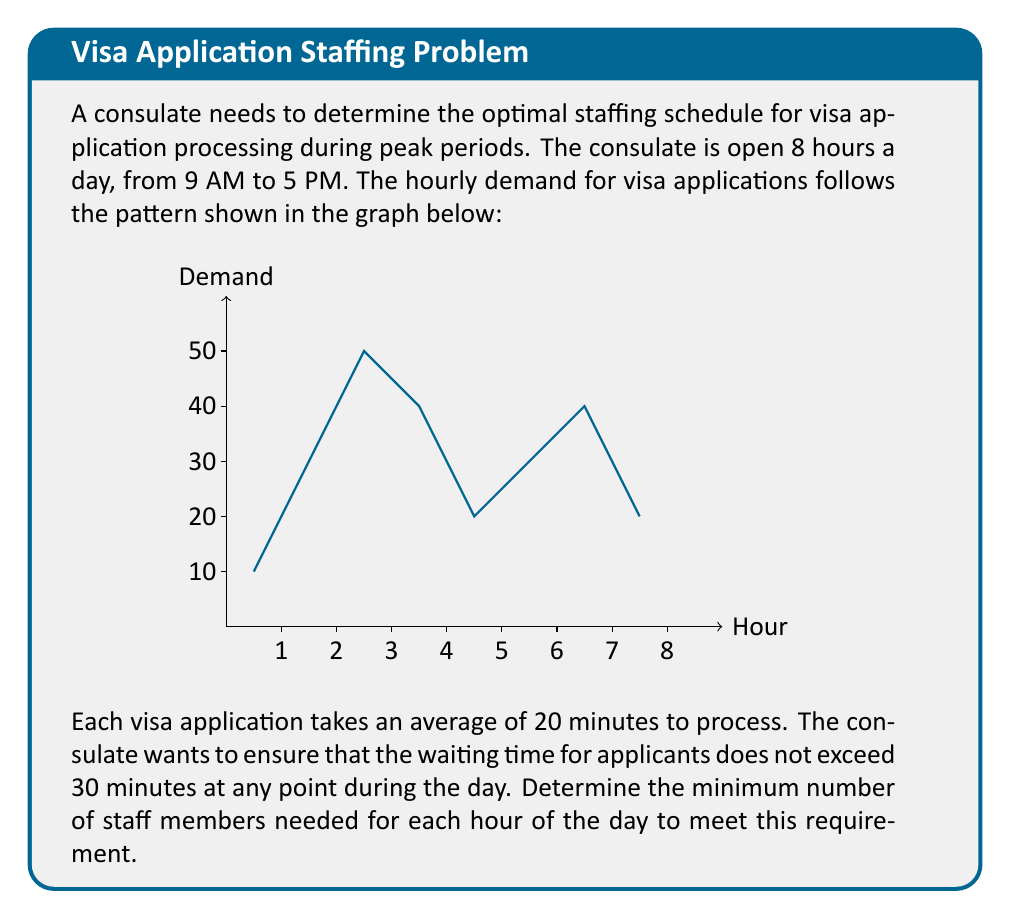Show me your answer to this math problem. Let's approach this problem step-by-step:

1) First, we need to calculate the number of applications that can be processed per hour per staff member:
   $$\text{Applications per hour} = \frac{60 \text{ minutes}}{20 \text{ minutes per application}} = 3$$

2) Now, for each hour, we need to calculate the number of staff required to process the incoming applications within 30 minutes:
   $$\text{Staff needed} = \left\lceil\frac{\text{Hourly demand}}{3 \times 0.5}\right\rceil$$
   Here, we multiply by 0.5 because we want to process all applications within 30 minutes (half an hour).

3) Let's calculate for each hour:

   Hour 1 (9-10 AM): $$\left\lceil\frac{10}{3 \times 0.5}\right\rceil = \left\lceil6.67\right\rceil = 7$$
   Hour 2 (10-11 AM): $$\left\lceil\frac{30}{3 \times 0.5}\right\rceil = \left\lceil20\right\rceil = 20$$
   Hour 3 (11-12 PM): $$\left\lceil\frac{50}{3 \times 0.5}\right\rceil = \left\lceil33.33\right\rceil = 34$$
   Hour 4 (12-1 PM): $$\left\lceil\frac{40}{3 \times 0.5}\right\rceil = \left\lceil26.67\right\rceil = 27$$
   Hour 5 (1-2 PM): $$\left\lceil\frac{20}{3 \times 0.5}\right\rceil = \left\lceil13.33\right\rceil = 14$$
   Hour 6 (2-3 PM): $$\left\lceil\frac{30}{3 \times 0.5}\right\rceil = \left\lceil20\right\rceil = 20$$
   Hour 7 (3-4 PM): $$\left\lceil\frac{40}{3 \times 0.5}\right\rceil = \left\lceil26.67\right\rceil = 27$$
   Hour 8 (4-5 PM): $$\left\lceil\frac{20}{3 \times 0.5}\right\rceil = \left\lceil13.33\right\rceil = 14$$

4) The optimal staffing schedule is the minimum number of staff needed for each hour to meet the 30-minute waiting time requirement.
Answer: 7, 20, 34, 27, 14, 20, 27, 14 